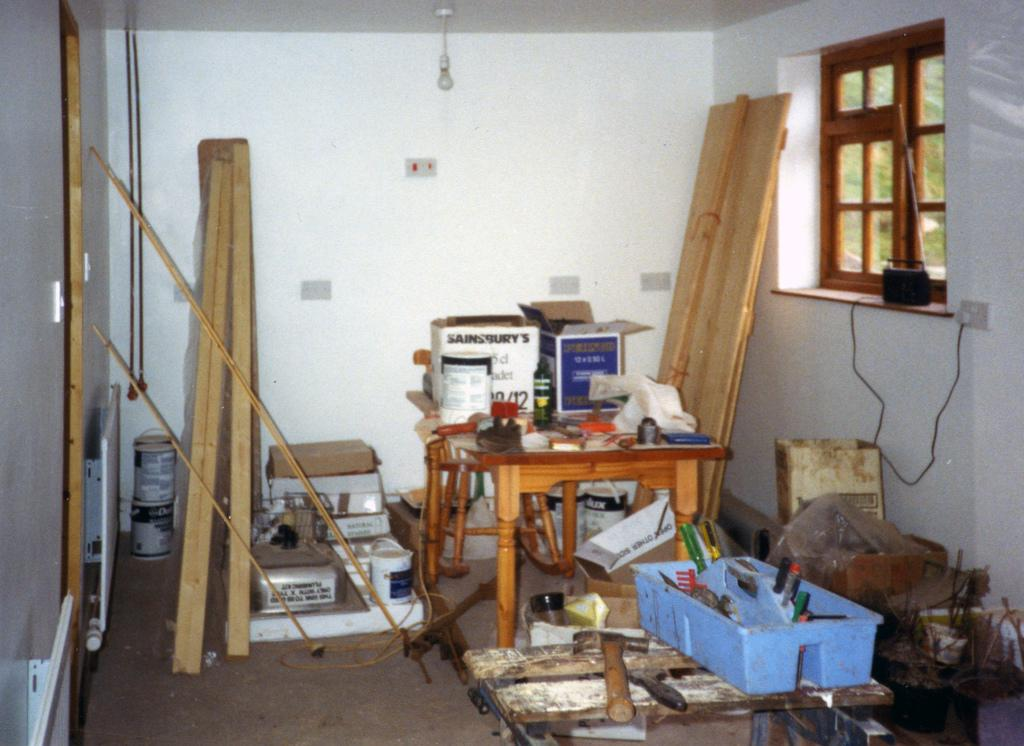What type of material is used for the objects in the image? The wooden objects in the image are made of wood. Where are the objects located in the image? The objects are on a table in the image. What tool is present in the image? There is a hammer in the image. What is the color and purpose of the basket in the image? The basket is blue and contains objects. What type of storage containers are in the image? There are boxes in the image. What architectural feature is visible in the image? There is a window in the image. What is the source of light in the image? There is light in the image. Can you describe any other objects in the room in the image? There are other objects in the room in the image. How many cattle are present in the image? There are no cattle present in the image. What type of throne is visible in the image? There is no throne present in the image. 